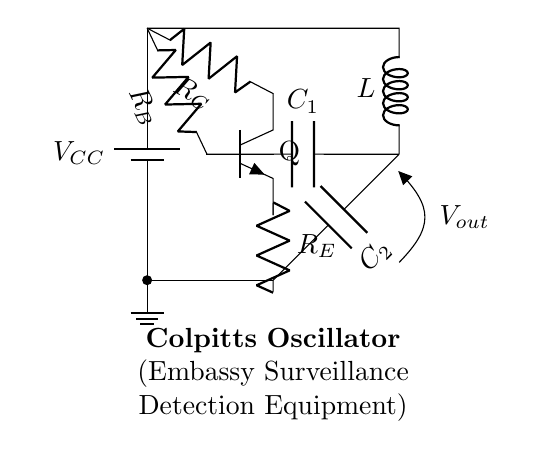What type of oscillator is represented in this circuit? The circuit diagram shows a Colpitts oscillator, identifiable by the configuration of its inductance and capacitance components in the feedback loop.
Answer: Colpitts What is the function of the transistor in this oscillator? The transistor, labeled Q, acts as a amplifying device, enabling the oscillator to generate the necessary signals by providing gain and maintaining oscillation.
Answer: Amplifier Which components form the frequency-determining network? The frequency-determining network is composed of two capacitors (C1 and C2) and an inductor (L), as they are connected in such a way to set the oscillation frequency based on their values.
Answer: C1, C2, L What is the role of the resistors in this circuit? The resistors (R_C, R_B, R_E) are used for biasing the transistor and ensuring proper operation conditions for the transistor to function effectively as an oscillator.
Answer: Biasing What is the output of this oscillator? The output is the voltage across the designated output node, labeled as V_out in the circuit diagram, which is the signal generated by the Colpitts oscillator.
Answer: V_out How does this oscillator maintain its oscillations? The oscillator maintains its oscillations through positive feedback provided by the reactive components (C1, C2, and L), which create a resonant circuit condition that reinforces the output signal over time.
Answer: Positive feedback 